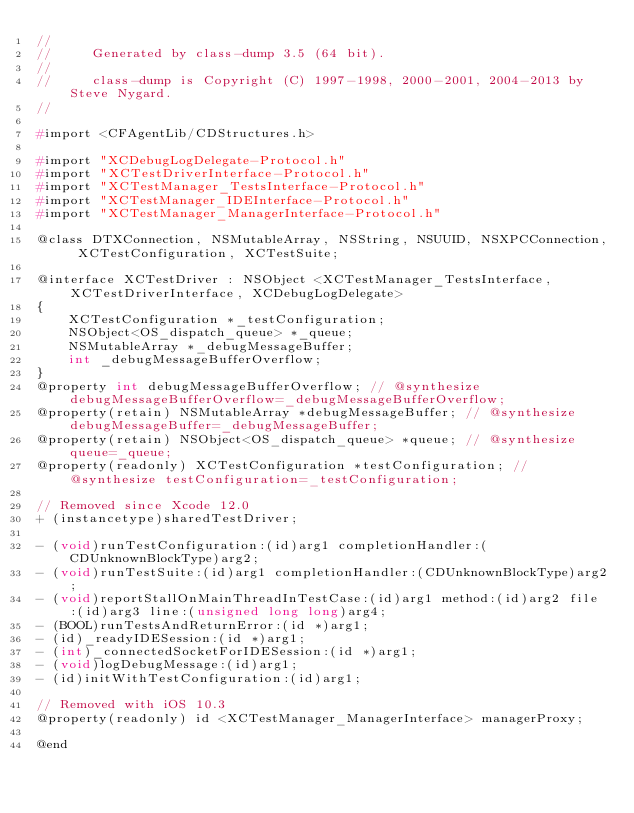<code> <loc_0><loc_0><loc_500><loc_500><_C_>//
//     Generated by class-dump 3.5 (64 bit).
//
//     class-dump is Copyright (C) 1997-1998, 2000-2001, 2004-2013 by Steve Nygard.
//

#import <CFAgentLib/CDStructures.h>

#import "XCDebugLogDelegate-Protocol.h"
#import "XCTestDriverInterface-Protocol.h"
#import "XCTestManager_TestsInterface-Protocol.h"
#import "XCTestManager_IDEInterface-Protocol.h"
#import "XCTestManager_ManagerInterface-Protocol.h"

@class DTXConnection, NSMutableArray, NSString, NSUUID, NSXPCConnection, XCTestConfiguration, XCTestSuite;

@interface XCTestDriver : NSObject <XCTestManager_TestsInterface, XCTestDriverInterface, XCDebugLogDelegate>
{
    XCTestConfiguration *_testConfiguration;
    NSObject<OS_dispatch_queue> *_queue;
    NSMutableArray *_debugMessageBuffer;
    int _debugMessageBufferOverflow;
}
@property int debugMessageBufferOverflow; // @synthesize debugMessageBufferOverflow=_debugMessageBufferOverflow;
@property(retain) NSMutableArray *debugMessageBuffer; // @synthesize debugMessageBuffer=_debugMessageBuffer;
@property(retain) NSObject<OS_dispatch_queue> *queue; // @synthesize queue=_queue;
@property(readonly) XCTestConfiguration *testConfiguration; // @synthesize testConfiguration=_testConfiguration;

// Removed since Xcode 12.0
+ (instancetype)sharedTestDriver;

- (void)runTestConfiguration:(id)arg1 completionHandler:(CDUnknownBlockType)arg2;
- (void)runTestSuite:(id)arg1 completionHandler:(CDUnknownBlockType)arg2;
- (void)reportStallOnMainThreadInTestCase:(id)arg1 method:(id)arg2 file:(id)arg3 line:(unsigned long long)arg4;
- (BOOL)runTestsAndReturnError:(id *)arg1;
- (id)_readyIDESession:(id *)arg1;
- (int)_connectedSocketForIDESession:(id *)arg1;
- (void)logDebugMessage:(id)arg1;
- (id)initWithTestConfiguration:(id)arg1;

// Removed with iOS 10.3
@property(readonly) id <XCTestManager_ManagerInterface> managerProxy;

@end
</code> 